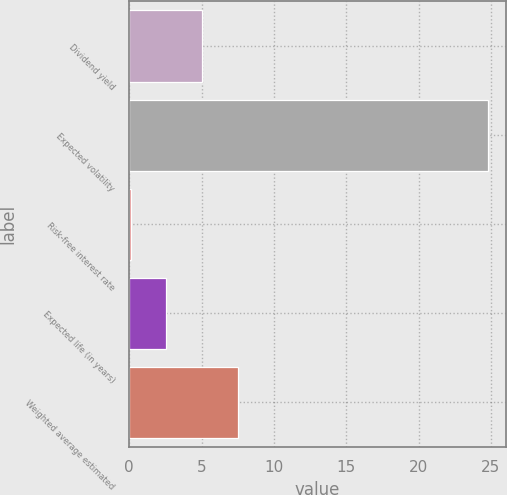<chart> <loc_0><loc_0><loc_500><loc_500><bar_chart><fcel>Dividend yield<fcel>Expected volatility<fcel>Risk-free interest rate<fcel>Expected life (in years)<fcel>Weighted average estimated<nl><fcel>5.03<fcel>24.8<fcel>0.09<fcel>2.56<fcel>7.5<nl></chart> 